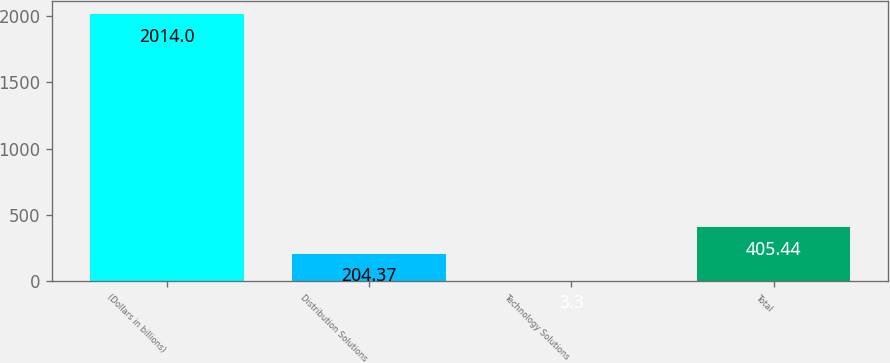Convert chart to OTSL. <chart><loc_0><loc_0><loc_500><loc_500><bar_chart><fcel>(Dollars in billions)<fcel>Distribution Solutions<fcel>Technology Solutions<fcel>Total<nl><fcel>2014<fcel>204.37<fcel>3.3<fcel>405.44<nl></chart> 